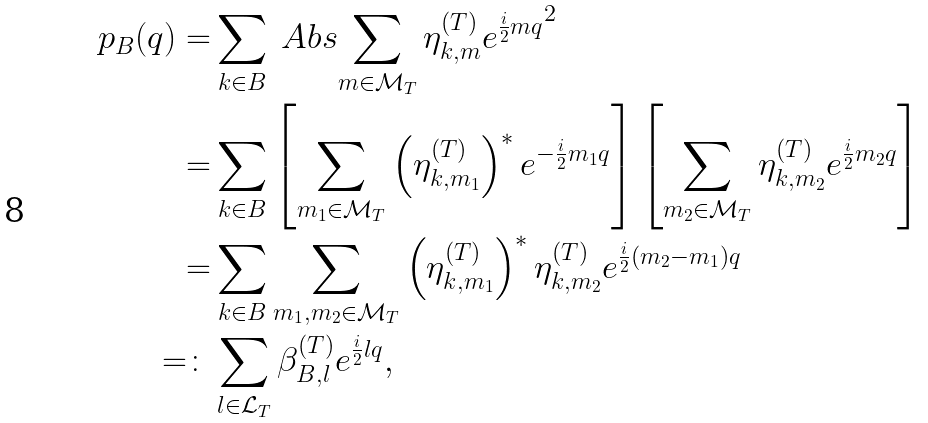Convert formula to latex. <formula><loc_0><loc_0><loc_500><loc_500>p _ { B } ( q ) = & \sum _ { k \in B } \ A b s { \sum _ { m \in \mathcal { M } _ { T } } \eta ^ { ( T ) } _ { k , m } e ^ { \frac { i } { 2 } m q } } ^ { 2 } \\ = & \sum _ { k \in B } \left [ \sum _ { m _ { 1 } \in \mathcal { M } _ { T } } \left ( \eta ^ { ( T ) } _ { k , m _ { 1 } } \right ) ^ { \ast } e ^ { - \frac { i } { 2 } m _ { 1 } q } \right ] \left [ \sum _ { m _ { 2 } \in \mathcal { M } _ { T } } \eta ^ { ( T ) } _ { k , m _ { 2 } } e ^ { \frac { i } { 2 } m _ { 2 } q } \right ] \\ = & \sum _ { k \in B } \sum _ { m _ { 1 } , m _ { 2 } \in \mathcal { M } _ { T } } \left ( \eta ^ { ( T ) } _ { k , m _ { 1 } } \right ) ^ { \ast } \eta ^ { ( T ) } _ { k , m _ { 2 } } e ^ { \frac { i } { 2 } ( m _ { 2 } - m _ { 1 } ) q } \\ = \colon & \sum _ { l \in \mathcal { L } _ { T } } \beta ^ { ( T ) } _ { B , l } e ^ { \frac { i } { 2 } l q } ,</formula> 